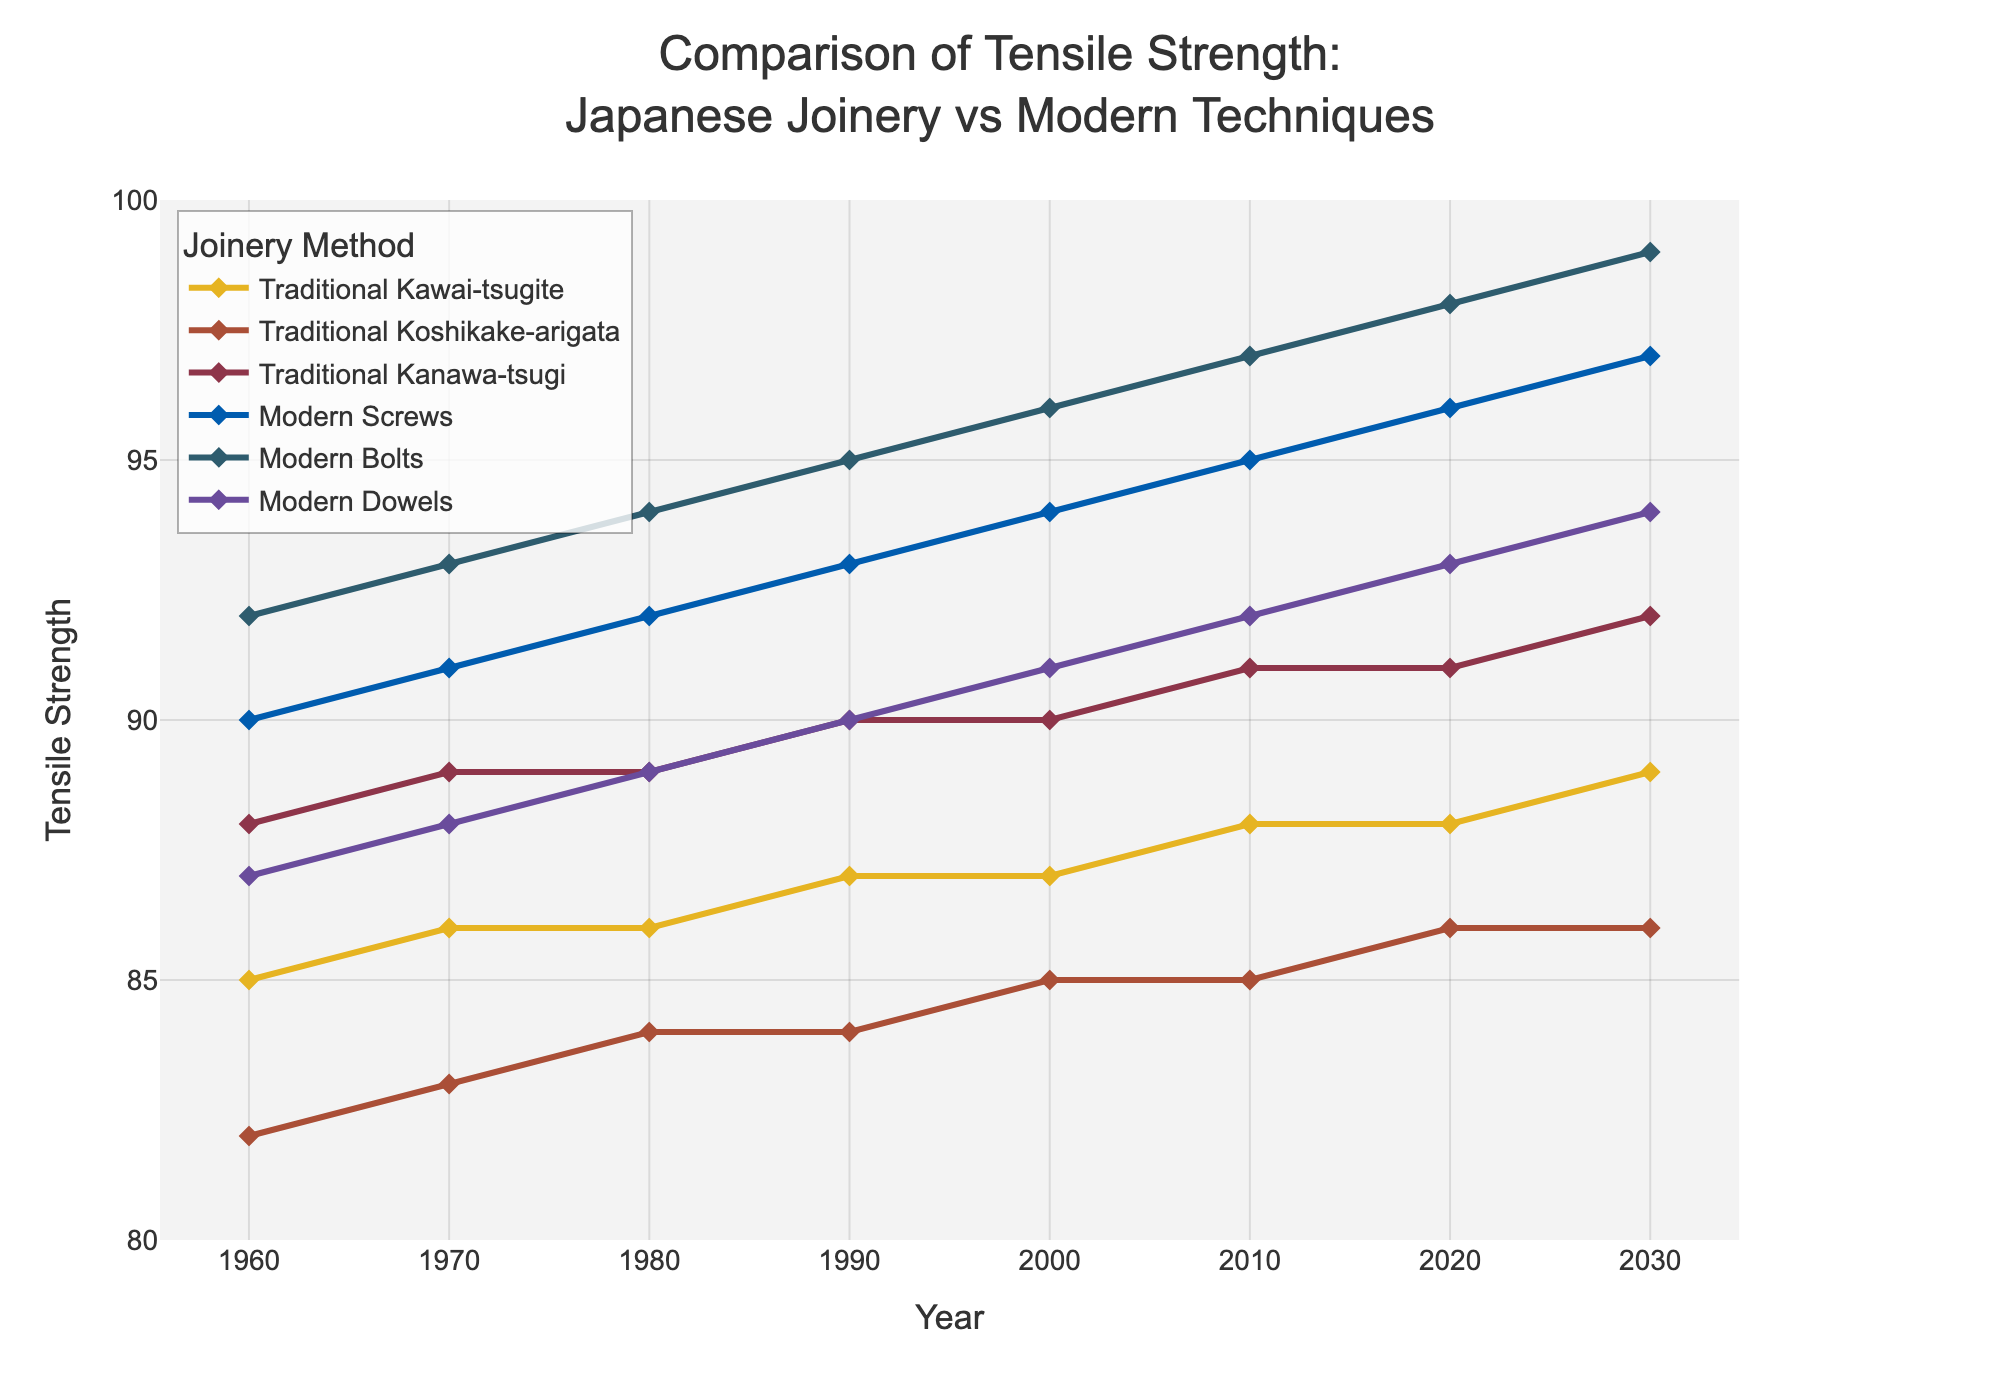What is the tensile strength of "Traditional Kawai-tsugite" in 2020? To find the tensile strength of "Traditional Kawai-tsugite" in 2020, locate the "Year" 2020 on the x-axis and check the corresponding value on the y-axis for the "Traditional Kawai-tsugite" line.
Answer: 88 Which joinery method had the highest tensile strength in 1980? Look at the y-values for all joinery methods in 1980. The method with the highest y-value has the highest tensile strength.
Answer: Modern Bolts What is the average tensile strength of "Modern Screws" from 1960 to 2030? Add the tensile strength values for "Modern Screws" from each year and divide by the number of years. (90+91+92+93+94+95+96+97)/8 = 93.5
Answer: 93.5 Which traditional joinery method shows the most improvement in tensile strength from 1960 to 2030? Calculate the difference in tensile strength from 1960 to 2030 for each traditional joinery method and find the one with the highest increase. ("Traditional Kawai-tsugite" 89-85 = 4, "Traditional Koshikake-arigata" 86-82 = 4, "Traditional Kanawa-tsugi" 92-88 = 4)
Answer: All equal improvement of 4 In which year did "Modern Dowels" overtake "Traditional Kanawa-tsugi" in tensile strength? Compare the tensile strength values of "Modern Dowels" and "Traditional Kanawa-tsugi" year by year to find the first year when "Modern Dowels" value is greater.
Answer: 2010 Between 2000 and 2020, which joinery method showed the least change in tensile strength? Calculate the change in tensile strength between 2000 and 2020 for each method and find the one with the smallest difference.
Answer: Traditional Koshikake-arigata How does the tensile strength of "Modern Bolts" in 1960 compare to "Traditional Kanawa-tsugi" in 2030? Compare the value of "Modern Bolts" in 1960 with the value of "Traditional Kanawa-tsugi" in 2030 to see if it is greater or lesser.
Answer: Modern Bolts in 1960 is higher Calculate the difference in tensile strength between "Modern Screws" and "Traditional Koshikake-arigata" in 1990. Subtract the tensile strength of "Traditional Koshikake-arigata" from "Modern Screws" in 1990. 93 - 84 = 9
Answer: 9 